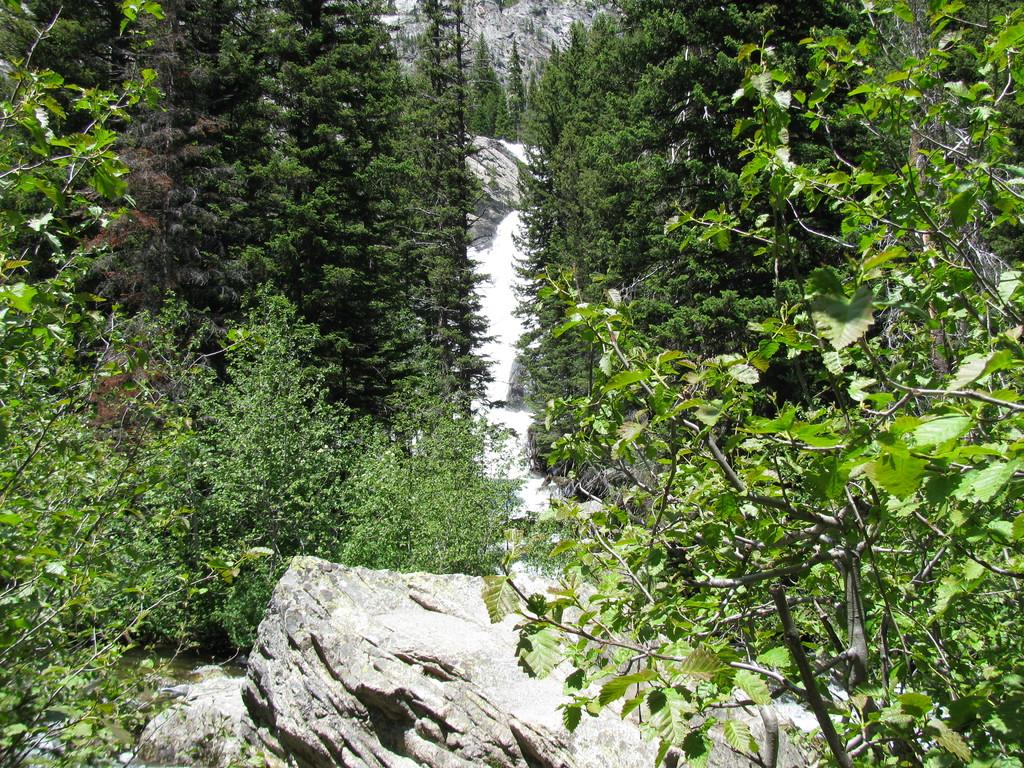What type of natural elements can be seen in the image? Rocks, trees, and plants can be seen in the image. Can you describe the trees in the image? There are trees in the image, and some of them are also present in the background. What other type of vegetation is visible in the image? Plants are visible in the image. What type of cream can be seen rolling down the rocks in the image? There is no cream present in the image, and therefore no such activity can be observed. 